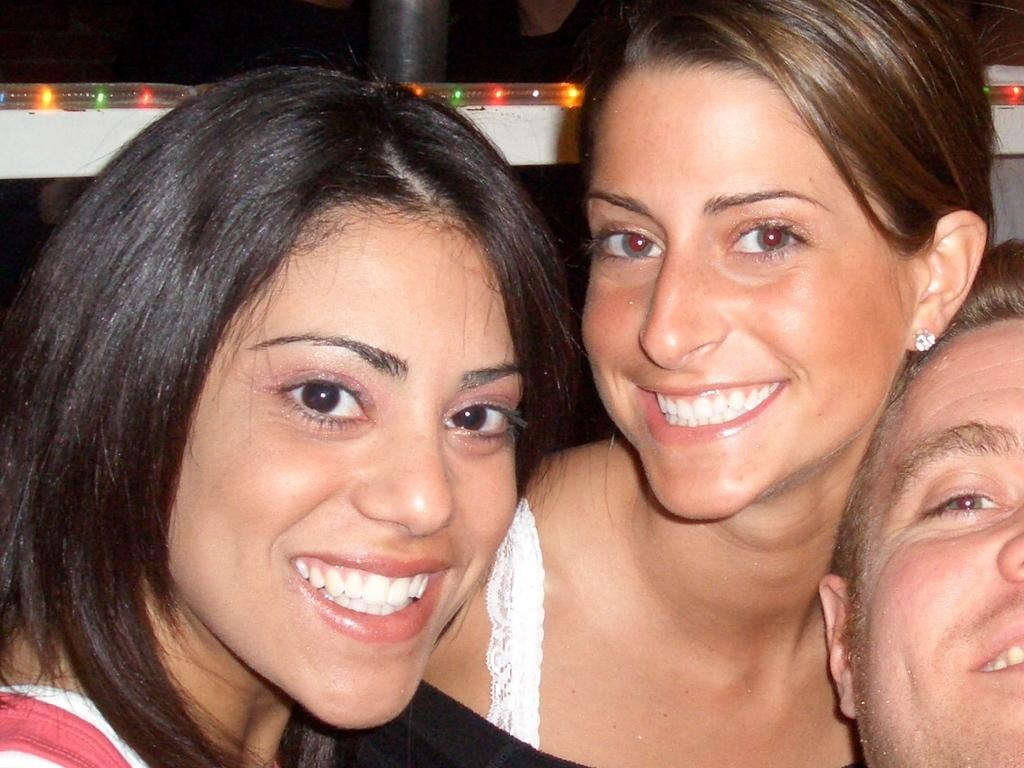What are the persons in the image doing? The persons in the image are sitting. What object can be seen in the image that is typically used for support or attachment? There is a pole visible in the image. What can be seen in the image that provides illumination? There are lights visible in the image. Can you tell me where the volcano is located in the image? There is no volcano present in the image. What type of crown is being worn by the person in the image? There is no person wearing a crown in the image. 